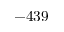<formula> <loc_0><loc_0><loc_500><loc_500>- 4 3 9</formula> 